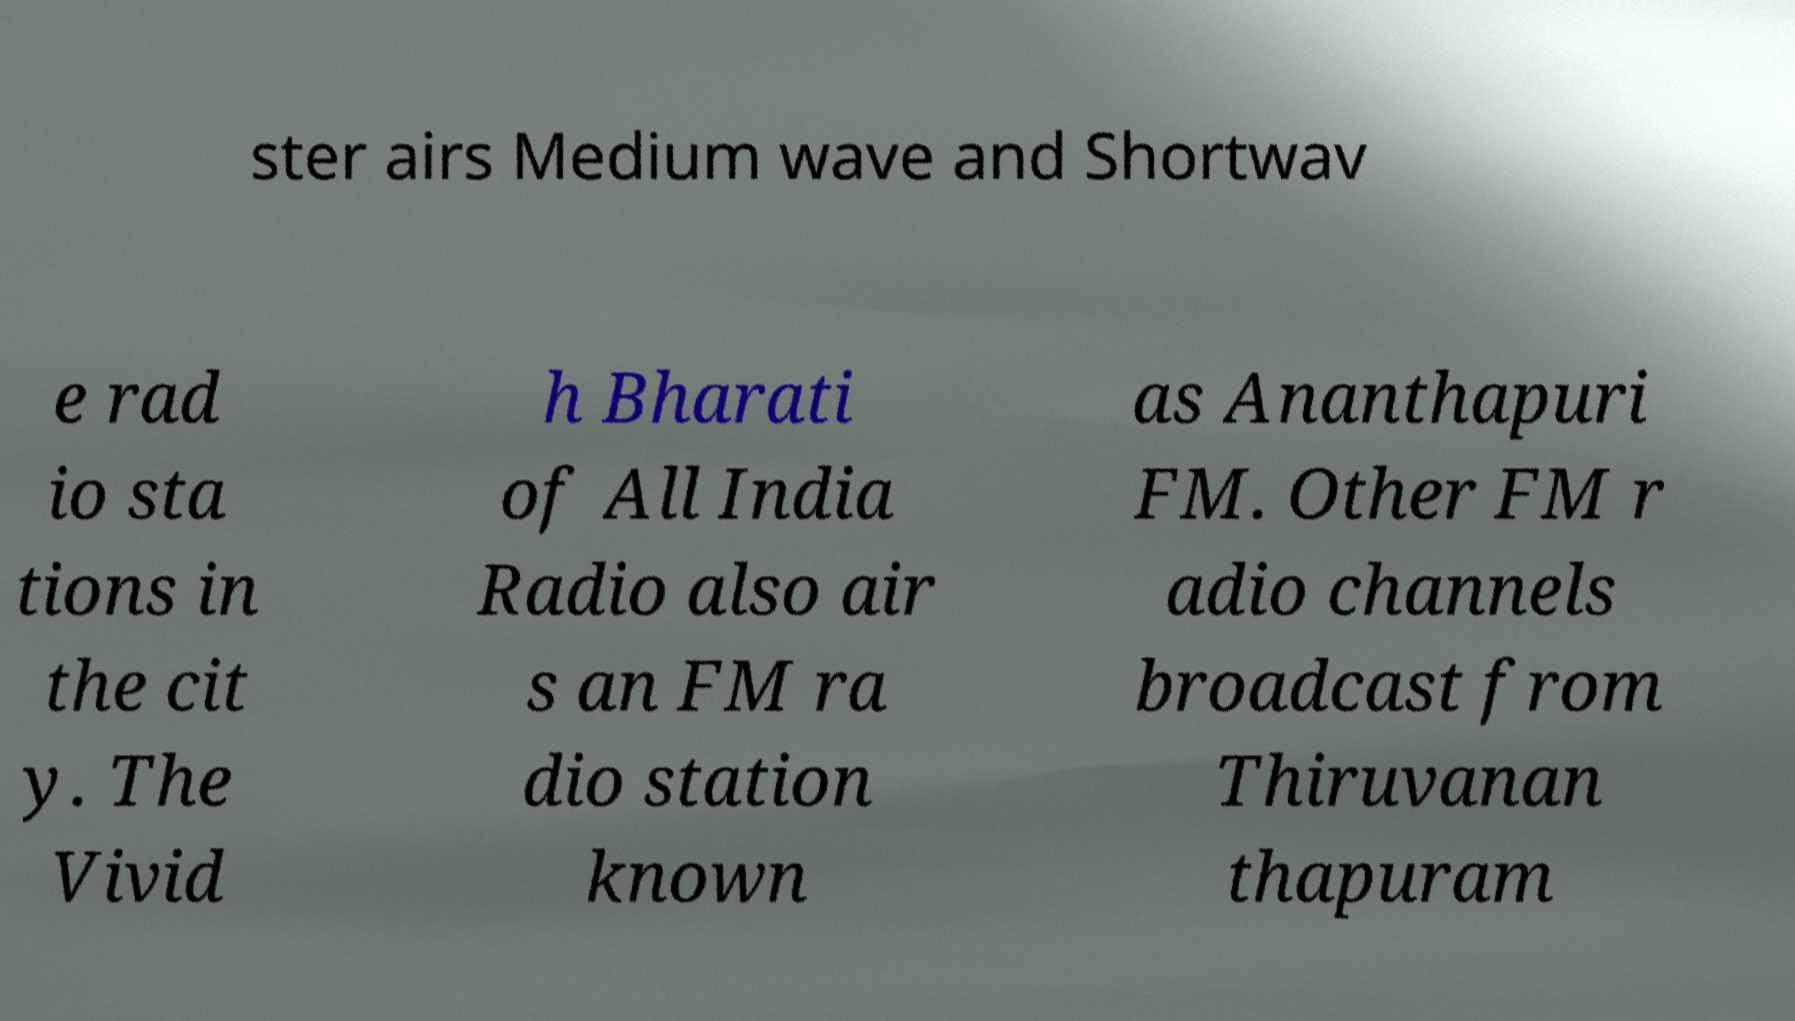Could you assist in decoding the text presented in this image and type it out clearly? ster airs Medium wave and Shortwav e rad io sta tions in the cit y. The Vivid h Bharati of All India Radio also air s an FM ra dio station known as Ananthapuri FM. Other FM r adio channels broadcast from Thiruvanan thapuram 